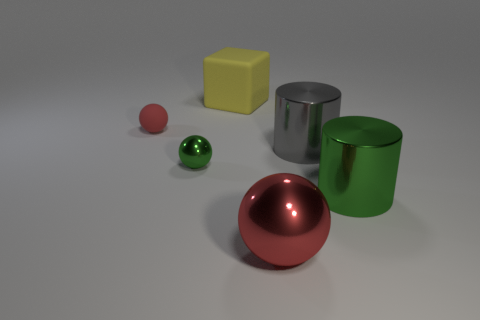What is the size of the metallic object that is the same color as the rubber sphere?
Your answer should be compact. Large. What number of brown things are tiny metallic balls or shiny things?
Provide a short and direct response. 0. What number of other objects are there of the same shape as the small red rubber thing?
Make the answer very short. 2. There is a metal cylinder in front of the big gray cylinder; is it the same color as the metal object to the left of the red shiny thing?
Make the answer very short. Yes. How many small things are gray shiny cylinders or green metal cylinders?
Your answer should be very brief. 0. What is the size of the other object that is the same shape as the gray thing?
Offer a terse response. Large. Is there any other thing that is the same size as the green shiny sphere?
Provide a succinct answer. Yes. What material is the red thing that is in front of the small object behind the gray metallic object?
Make the answer very short. Metal. How many metallic objects are either blocks or small green objects?
Give a very brief answer. 1. There is a small matte thing that is the same shape as the red shiny object; what is its color?
Keep it short and to the point. Red. 